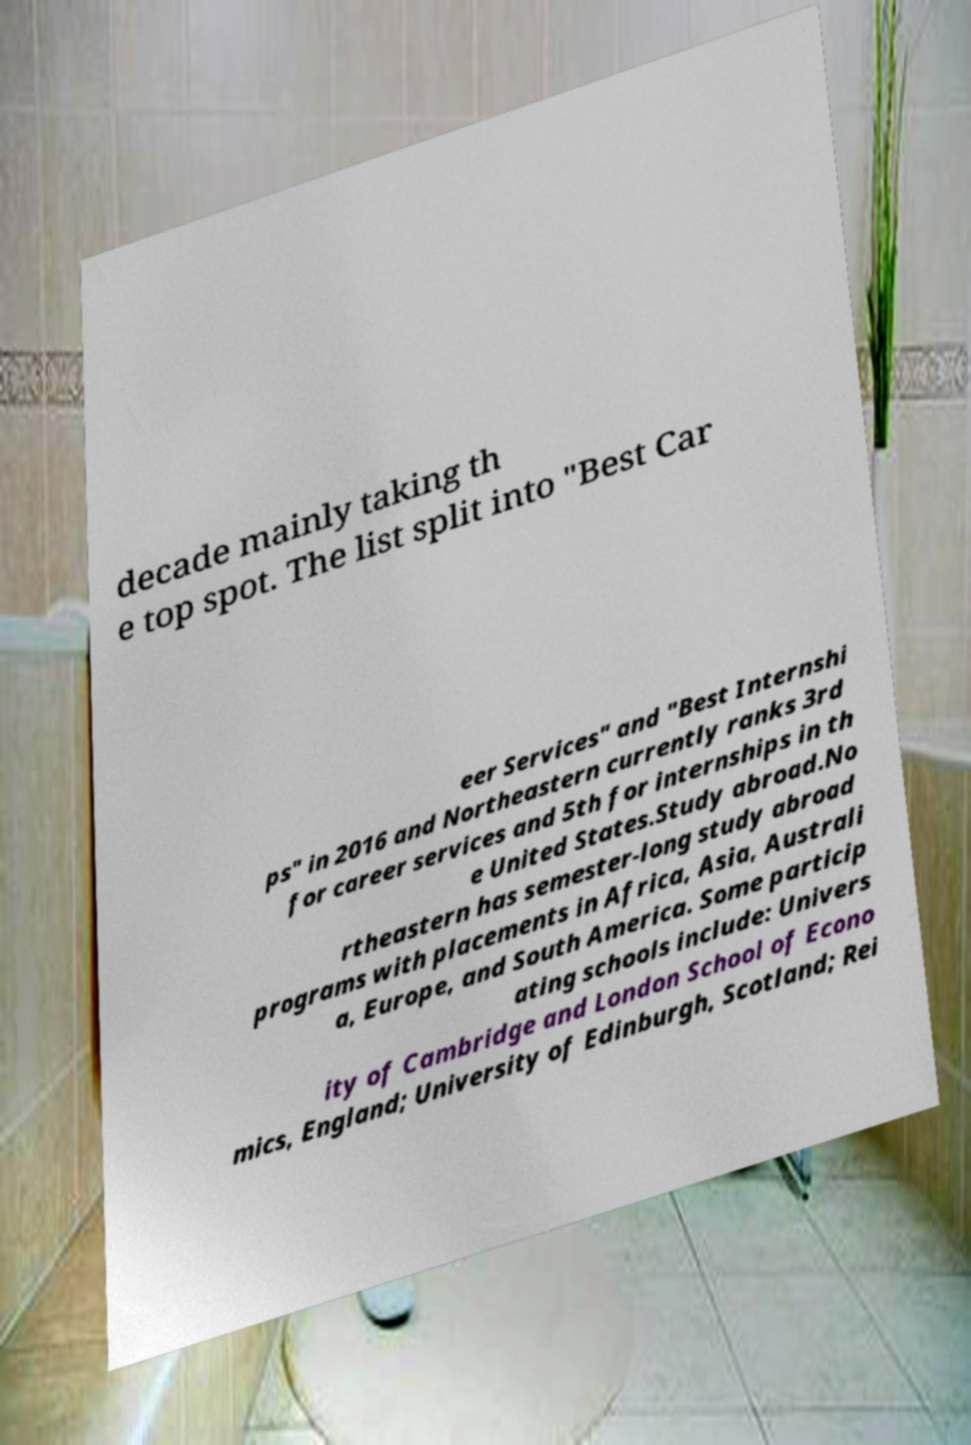Could you assist in decoding the text presented in this image and type it out clearly? decade mainly taking th e top spot. The list split into "Best Car eer Services" and "Best Internshi ps" in 2016 and Northeastern currently ranks 3rd for career services and 5th for internships in th e United States.Study abroad.No rtheastern has semester-long study abroad programs with placements in Africa, Asia, Australi a, Europe, and South America. Some particip ating schools include: Univers ity of Cambridge and London School of Econo mics, England; University of Edinburgh, Scotland; Rei 